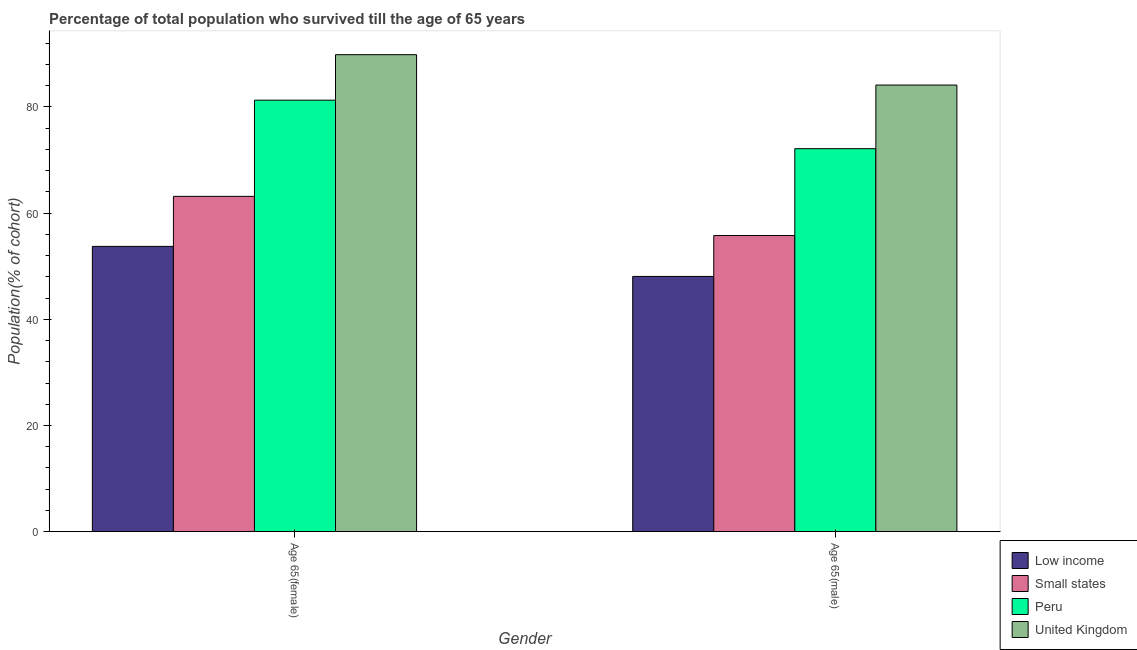How many different coloured bars are there?
Your response must be concise. 4. Are the number of bars per tick equal to the number of legend labels?
Your answer should be very brief. Yes. Are the number of bars on each tick of the X-axis equal?
Provide a succinct answer. Yes. How many bars are there on the 2nd tick from the left?
Your answer should be very brief. 4. How many bars are there on the 1st tick from the right?
Provide a short and direct response. 4. What is the label of the 1st group of bars from the left?
Offer a terse response. Age 65(female). What is the percentage of female population who survived till age of 65 in Peru?
Provide a succinct answer. 81.26. Across all countries, what is the maximum percentage of female population who survived till age of 65?
Offer a very short reply. 89.83. Across all countries, what is the minimum percentage of male population who survived till age of 65?
Offer a very short reply. 48.07. In which country was the percentage of male population who survived till age of 65 maximum?
Provide a succinct answer. United Kingdom. In which country was the percentage of female population who survived till age of 65 minimum?
Provide a succinct answer. Low income. What is the total percentage of male population who survived till age of 65 in the graph?
Your response must be concise. 260.09. What is the difference between the percentage of female population who survived till age of 65 in Peru and that in Low income?
Your answer should be very brief. 27.53. What is the difference between the percentage of female population who survived till age of 65 in Peru and the percentage of male population who survived till age of 65 in United Kingdom?
Offer a terse response. -2.85. What is the average percentage of male population who survived till age of 65 per country?
Give a very brief answer. 65.02. What is the difference between the percentage of female population who survived till age of 65 and percentage of male population who survived till age of 65 in Low income?
Give a very brief answer. 5.66. What is the ratio of the percentage of female population who survived till age of 65 in United Kingdom to that in Low income?
Offer a very short reply. 1.67. Is the percentage of female population who survived till age of 65 in Small states less than that in Low income?
Keep it short and to the point. No. What does the 4th bar from the left in Age 65(female) represents?
Your answer should be compact. United Kingdom. What does the 3rd bar from the right in Age 65(female) represents?
Make the answer very short. Small states. How many bars are there?
Give a very brief answer. 8. Are all the bars in the graph horizontal?
Provide a short and direct response. No. How many countries are there in the graph?
Make the answer very short. 4. What is the difference between two consecutive major ticks on the Y-axis?
Provide a succinct answer. 20. Are the values on the major ticks of Y-axis written in scientific E-notation?
Your answer should be very brief. No. How many legend labels are there?
Your answer should be very brief. 4. What is the title of the graph?
Make the answer very short. Percentage of total population who survived till the age of 65 years. Does "Namibia" appear as one of the legend labels in the graph?
Ensure brevity in your answer.  No. What is the label or title of the Y-axis?
Your answer should be very brief. Population(% of cohort). What is the Population(% of cohort) of Low income in Age 65(female)?
Provide a succinct answer. 53.73. What is the Population(% of cohort) of Small states in Age 65(female)?
Provide a short and direct response. 63.15. What is the Population(% of cohort) of Peru in Age 65(female)?
Give a very brief answer. 81.26. What is the Population(% of cohort) in United Kingdom in Age 65(female)?
Your answer should be compact. 89.83. What is the Population(% of cohort) in Low income in Age 65(male)?
Provide a succinct answer. 48.07. What is the Population(% of cohort) of Small states in Age 65(male)?
Keep it short and to the point. 55.78. What is the Population(% of cohort) of Peru in Age 65(male)?
Your response must be concise. 72.13. What is the Population(% of cohort) of United Kingdom in Age 65(male)?
Your answer should be very brief. 84.11. Across all Gender, what is the maximum Population(% of cohort) of Low income?
Provide a short and direct response. 53.73. Across all Gender, what is the maximum Population(% of cohort) of Small states?
Keep it short and to the point. 63.15. Across all Gender, what is the maximum Population(% of cohort) in Peru?
Your answer should be very brief. 81.26. Across all Gender, what is the maximum Population(% of cohort) of United Kingdom?
Offer a terse response. 89.83. Across all Gender, what is the minimum Population(% of cohort) in Low income?
Keep it short and to the point. 48.07. Across all Gender, what is the minimum Population(% of cohort) in Small states?
Your response must be concise. 55.78. Across all Gender, what is the minimum Population(% of cohort) of Peru?
Offer a very short reply. 72.13. Across all Gender, what is the minimum Population(% of cohort) in United Kingdom?
Offer a very short reply. 84.11. What is the total Population(% of cohort) of Low income in the graph?
Provide a succinct answer. 101.8. What is the total Population(% of cohort) in Small states in the graph?
Provide a short and direct response. 118.93. What is the total Population(% of cohort) in Peru in the graph?
Your response must be concise. 153.39. What is the total Population(% of cohort) of United Kingdom in the graph?
Your answer should be compact. 173.94. What is the difference between the Population(% of cohort) in Low income in Age 65(female) and that in Age 65(male)?
Ensure brevity in your answer.  5.66. What is the difference between the Population(% of cohort) in Small states in Age 65(female) and that in Age 65(male)?
Provide a succinct answer. 7.38. What is the difference between the Population(% of cohort) in Peru in Age 65(female) and that in Age 65(male)?
Offer a very short reply. 9.13. What is the difference between the Population(% of cohort) of United Kingdom in Age 65(female) and that in Age 65(male)?
Make the answer very short. 5.72. What is the difference between the Population(% of cohort) of Low income in Age 65(female) and the Population(% of cohort) of Small states in Age 65(male)?
Keep it short and to the point. -2.04. What is the difference between the Population(% of cohort) of Low income in Age 65(female) and the Population(% of cohort) of Peru in Age 65(male)?
Your answer should be compact. -18.4. What is the difference between the Population(% of cohort) in Low income in Age 65(female) and the Population(% of cohort) in United Kingdom in Age 65(male)?
Provide a short and direct response. -30.38. What is the difference between the Population(% of cohort) of Small states in Age 65(female) and the Population(% of cohort) of Peru in Age 65(male)?
Your answer should be compact. -8.98. What is the difference between the Population(% of cohort) of Small states in Age 65(female) and the Population(% of cohort) of United Kingdom in Age 65(male)?
Keep it short and to the point. -20.96. What is the difference between the Population(% of cohort) in Peru in Age 65(female) and the Population(% of cohort) in United Kingdom in Age 65(male)?
Your answer should be compact. -2.85. What is the average Population(% of cohort) in Low income per Gender?
Keep it short and to the point. 50.9. What is the average Population(% of cohort) of Small states per Gender?
Keep it short and to the point. 59.46. What is the average Population(% of cohort) of Peru per Gender?
Your response must be concise. 76.7. What is the average Population(% of cohort) in United Kingdom per Gender?
Your answer should be compact. 86.97. What is the difference between the Population(% of cohort) in Low income and Population(% of cohort) in Small states in Age 65(female)?
Your answer should be very brief. -9.42. What is the difference between the Population(% of cohort) of Low income and Population(% of cohort) of Peru in Age 65(female)?
Offer a very short reply. -27.53. What is the difference between the Population(% of cohort) of Low income and Population(% of cohort) of United Kingdom in Age 65(female)?
Offer a terse response. -36.1. What is the difference between the Population(% of cohort) of Small states and Population(% of cohort) of Peru in Age 65(female)?
Make the answer very short. -18.11. What is the difference between the Population(% of cohort) in Small states and Population(% of cohort) in United Kingdom in Age 65(female)?
Your response must be concise. -26.68. What is the difference between the Population(% of cohort) of Peru and Population(% of cohort) of United Kingdom in Age 65(female)?
Your response must be concise. -8.57. What is the difference between the Population(% of cohort) of Low income and Population(% of cohort) of Small states in Age 65(male)?
Give a very brief answer. -7.7. What is the difference between the Population(% of cohort) of Low income and Population(% of cohort) of Peru in Age 65(male)?
Provide a short and direct response. -24.06. What is the difference between the Population(% of cohort) in Low income and Population(% of cohort) in United Kingdom in Age 65(male)?
Offer a terse response. -36.04. What is the difference between the Population(% of cohort) in Small states and Population(% of cohort) in Peru in Age 65(male)?
Offer a terse response. -16.36. What is the difference between the Population(% of cohort) in Small states and Population(% of cohort) in United Kingdom in Age 65(male)?
Ensure brevity in your answer.  -28.34. What is the difference between the Population(% of cohort) of Peru and Population(% of cohort) of United Kingdom in Age 65(male)?
Provide a short and direct response. -11.98. What is the ratio of the Population(% of cohort) in Low income in Age 65(female) to that in Age 65(male)?
Offer a terse response. 1.12. What is the ratio of the Population(% of cohort) of Small states in Age 65(female) to that in Age 65(male)?
Give a very brief answer. 1.13. What is the ratio of the Population(% of cohort) in Peru in Age 65(female) to that in Age 65(male)?
Offer a terse response. 1.13. What is the ratio of the Population(% of cohort) of United Kingdom in Age 65(female) to that in Age 65(male)?
Your response must be concise. 1.07. What is the difference between the highest and the second highest Population(% of cohort) of Low income?
Make the answer very short. 5.66. What is the difference between the highest and the second highest Population(% of cohort) of Small states?
Ensure brevity in your answer.  7.38. What is the difference between the highest and the second highest Population(% of cohort) of Peru?
Ensure brevity in your answer.  9.13. What is the difference between the highest and the second highest Population(% of cohort) of United Kingdom?
Your response must be concise. 5.72. What is the difference between the highest and the lowest Population(% of cohort) of Low income?
Your answer should be compact. 5.66. What is the difference between the highest and the lowest Population(% of cohort) in Small states?
Give a very brief answer. 7.38. What is the difference between the highest and the lowest Population(% of cohort) in Peru?
Make the answer very short. 9.13. What is the difference between the highest and the lowest Population(% of cohort) in United Kingdom?
Offer a very short reply. 5.72. 